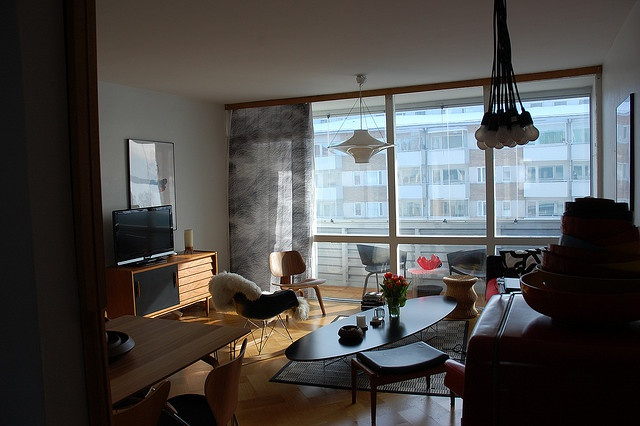Describe the objects in this image and their specific colors. I can see dining table in black, maroon, and brown tones, tv in black, gray, darkblue, and darkgray tones, chair in black, maroon, and tan tones, chair in black, maroon, and gray tones, and couch in black, gray, maroon, and lightblue tones in this image. 